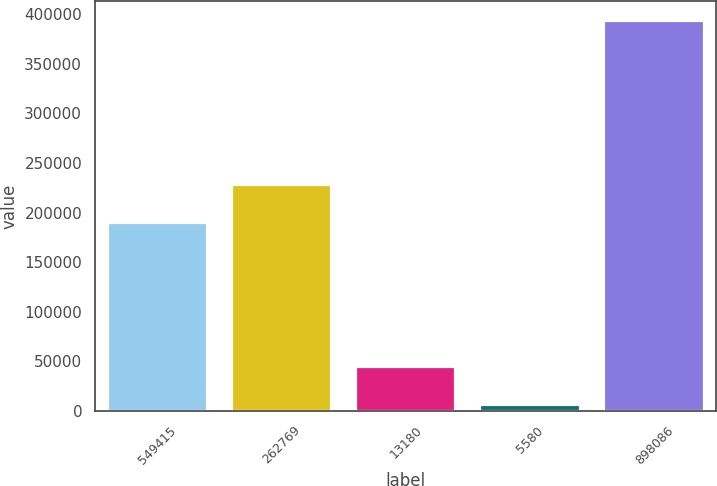<chart> <loc_0><loc_0><loc_500><loc_500><bar_chart><fcel>549415<fcel>262769<fcel>13180<fcel>5580<fcel>898086<nl><fcel>189149<fcel>227990<fcel>44099.1<fcel>5258<fcel>393669<nl></chart> 